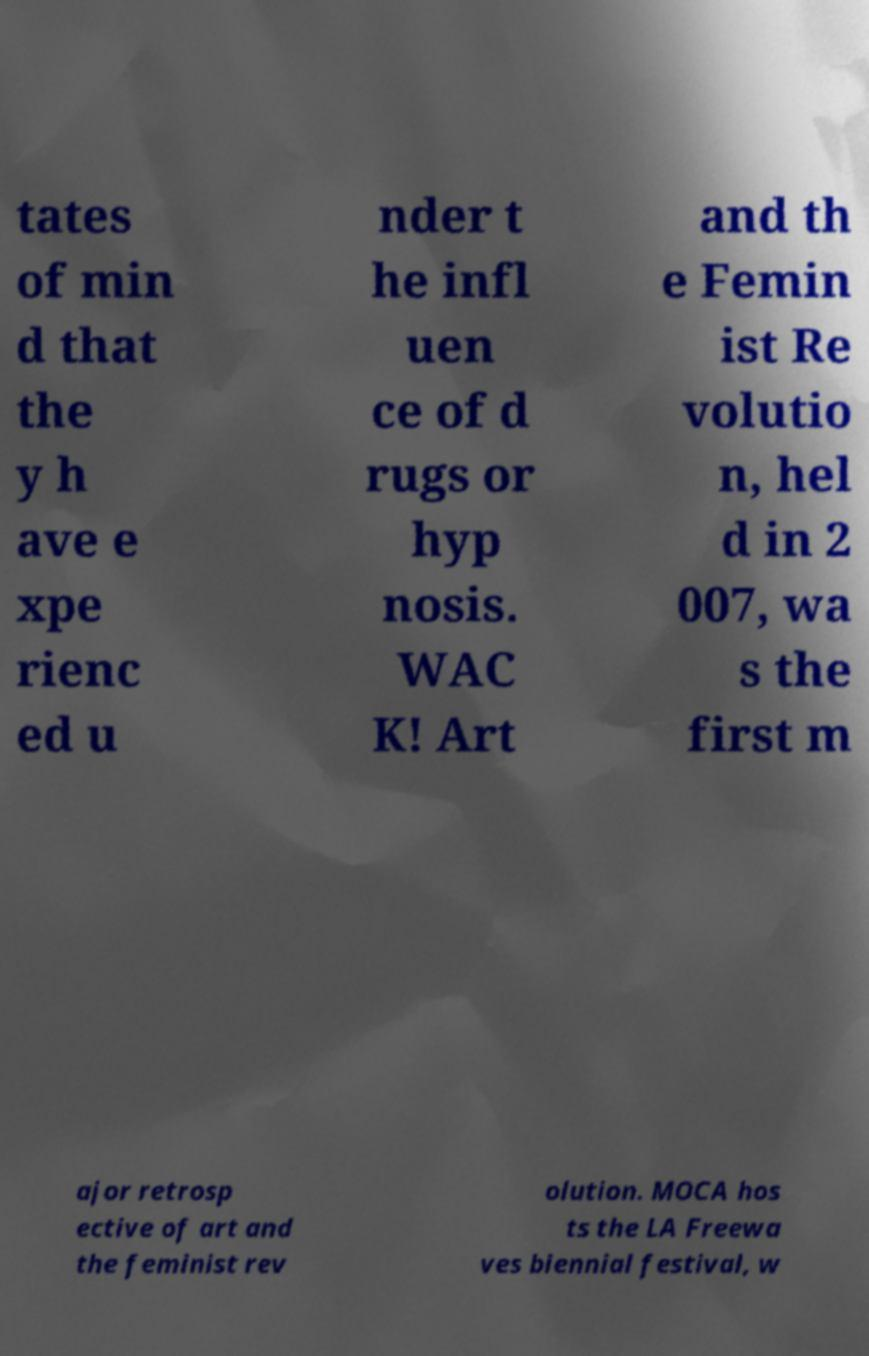There's text embedded in this image that I need extracted. Can you transcribe it verbatim? tates of min d that the y h ave e xpe rienc ed u nder t he infl uen ce of d rugs or hyp nosis. WAC K! Art and th e Femin ist Re volutio n, hel d in 2 007, wa s the first m ajor retrosp ective of art and the feminist rev olution. MOCA hos ts the LA Freewa ves biennial festival, w 